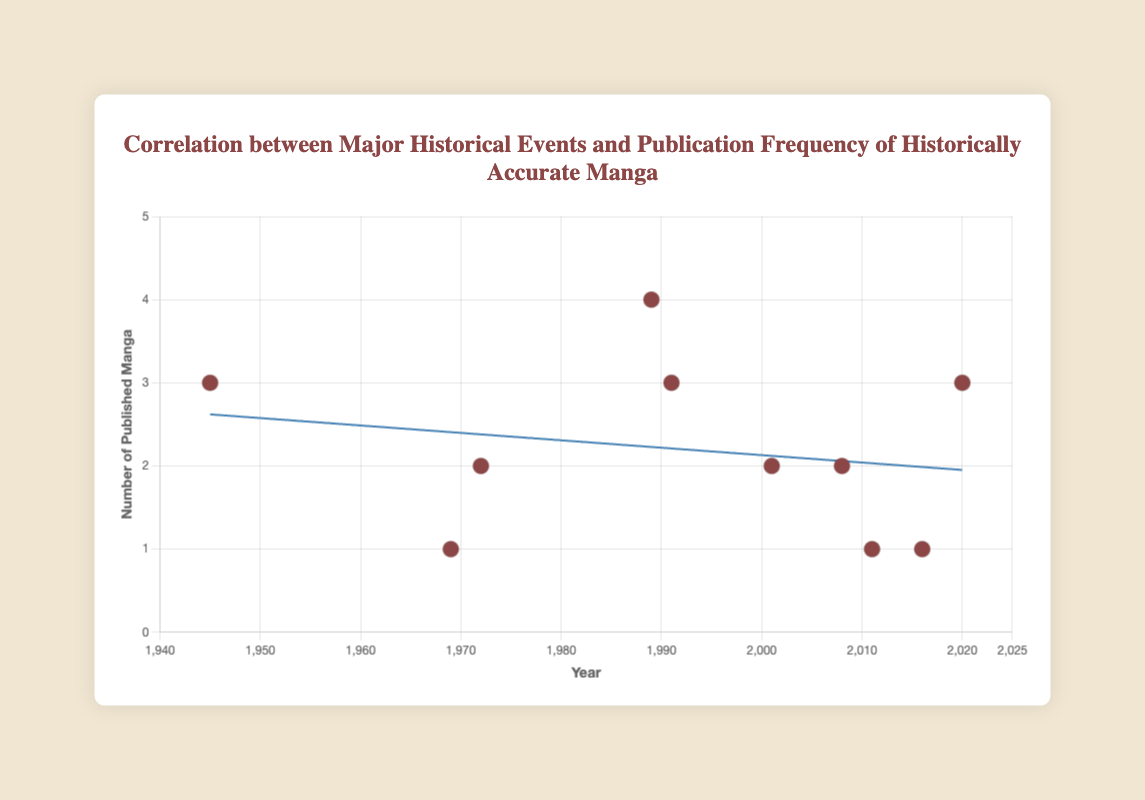What is the title of the chart? The chart's title is displayed prominently at the top, showing the main focus of the figure.
Answer: Correlation between Major Historical Events and Publication Frequency of Historically Accurate Manga What is the range of years displayed on the x-axis? The x-axis represents years and stretches from 1940 to 2025, allowing us to see the timeline of historical events and their related manga publications.
Answer: 1940 to 2025 How many manga were published in the year 1989? By locating the year 1989 on the x-axis and looking at the corresponding data point, we see that it is positioned at 4 on the y-axis, indicating the number of published manga.
Answer: 4 Which year had the highest number of published manga and how many were published? Observing the heights of the data points along the y-axis, the tallest point represents the highest frequency. The year 1989 corresponds to 4 published manga, which is the highest.
Answer: 1989, 4 How many historical events are plotted in the scatter chart? Each data point on the scatter plot corresponds to an event. By counting these points, we find there are 10 individual events.
Answer: 10 What is the visible pattern or trend shown by the trend line? The trend line illustrates a general direction in the data. Observing its slope helps determine if there is an upward, downward, or no significant trend in manga publications over the years. The trend line is relatively flat, suggesting no significant change over time.
Answer: Relatively flat, no significant change What was the number of published manga immediately after the end of World War II (in 1945) compared to the publications during the Vietnam War End (in 1972)? Comparing the y-values of the data points for the years 1945 and 1972 shows that both have data points located at 3 and 2 respectively, indicating the number of published manga.
Answer: 1945 had 3, 1972 had 2 Is there a consistent increase in the number of published manga over the years? To determine consistency, the individual data points and the trend line must be examined carefully. While there are fluctuations, the trend line indicates no consistent increase or decrease.
Answer: No consistent increase How does the number of published manga during the COVID-19 Pandemic (2020) compare to those during the Global Financial Crisis (2008)? Observing the y-values for 2020 and 2008, we see that they are 3 and 2, respectively, with the 2020 value being higher.
Answer: 2020 had 3, 2008 had 2 Which event has the least number of published manga, and how many were published? Identifying the lowest y-value among all data points, the Brexit event at the year 2016 appears at the lowest point with a value of 1.
Answer: Brexit (2016), 1 